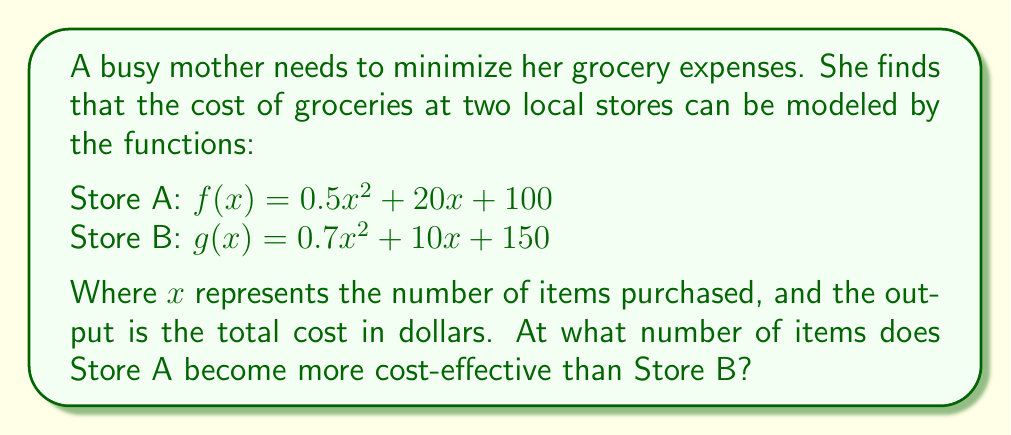Teach me how to tackle this problem. To find the point where Store A becomes more cost-effective, we need to determine when the cost at Store A becomes less than the cost at Store B. This occurs when $f(x) = g(x)$.

1) Set up the equation:
   $f(x) = g(x)$
   $0.5x^2 + 20x + 100 = 0.7x^2 + 10x + 150$

2) Rearrange the equation:
   $0.5x^2 + 20x + 100 - (0.7x^2 + 10x + 150) = 0$
   $-0.2x^2 + 10x - 50 = 0$

3) Multiply all terms by -5 to simplify:
   $x^2 - 50x + 250 = 0$

4) This is a quadratic equation. We can solve it using the quadratic formula:
   $x = \frac{-b \pm \sqrt{b^2 - 4ac}}{2a}$

   Where $a = 1$, $b = -50$, and $c = 250$

5) Substituting into the quadratic formula:
   $x = \frac{50 \pm \sqrt{(-50)^2 - 4(1)(250)}}{2(1)}$
   $x = \frac{50 \pm \sqrt{2500 - 1000}}{2}$
   $x = \frac{50 \pm \sqrt{1500}}{2}$
   $x = \frac{50 \pm 10\sqrt{15}}{2}$

6) This gives us two solutions:
   $x_1 = \frac{50 + 10\sqrt{15}}{2} \approx 44.35$
   $x_2 = \frac{50 - 10\sqrt{15}}{2} \approx 5.65$

7) Since we're looking for the point where Store A becomes more cost-effective, we want the larger solution. Store A becomes more cost-effective after approximately 44.35 items.

8) Since we can only purchase whole items, we round up to 45 items.
Answer: 45 items 